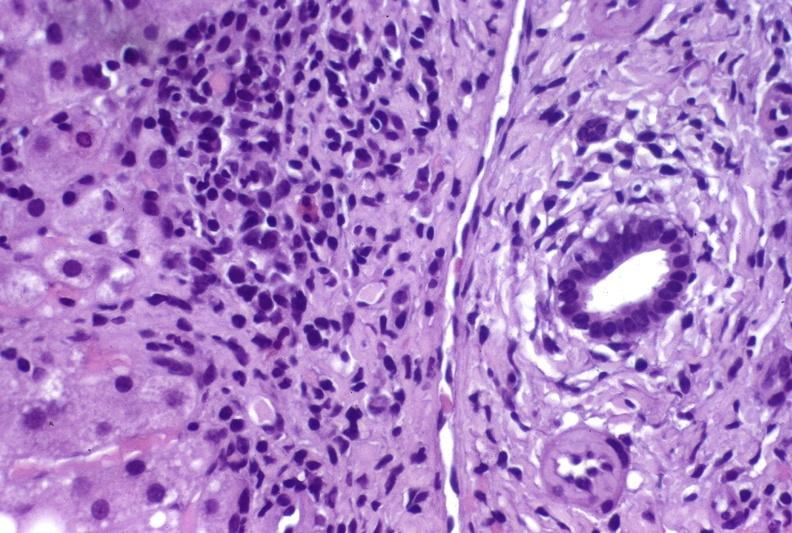what does this image show?
Answer the question using a single word or phrase. Hepatitis c virus 